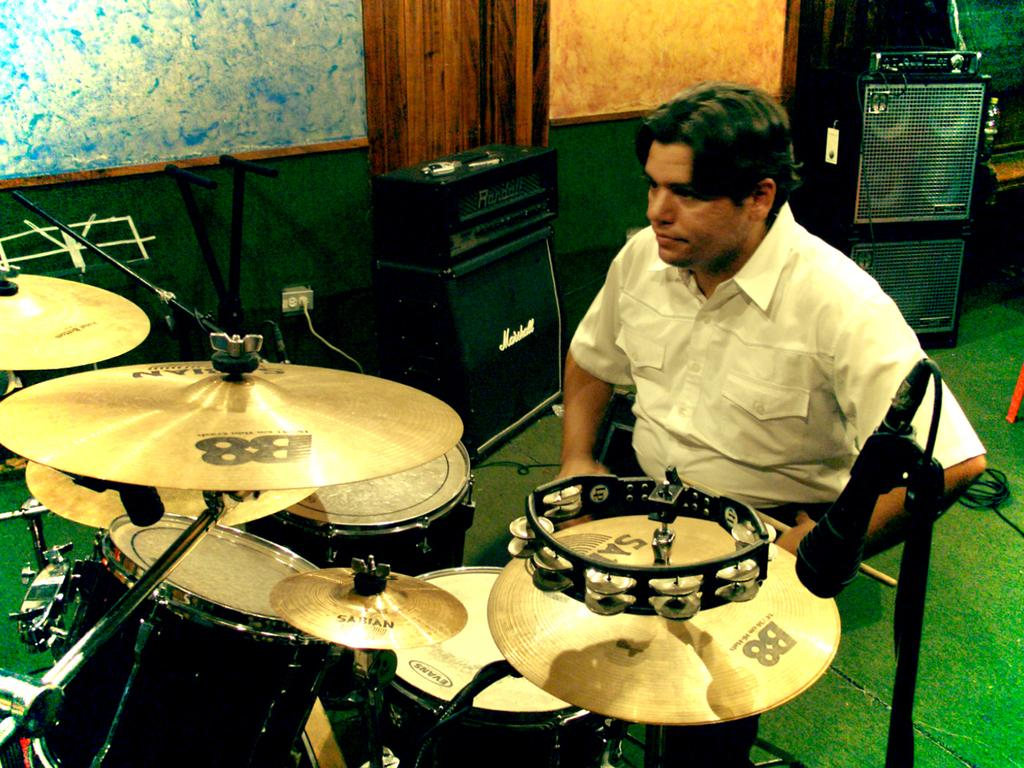What can be seen in the image? There is a person and music equipment in the image. What type of equipment is present in the image? There are speakers in the image. Where are the music equipment and speakers located? They are placed on a green carpet. How does the chicken contribute to the pollution in the image? There is no chicken present in the image, so it cannot contribute to any pollution. 